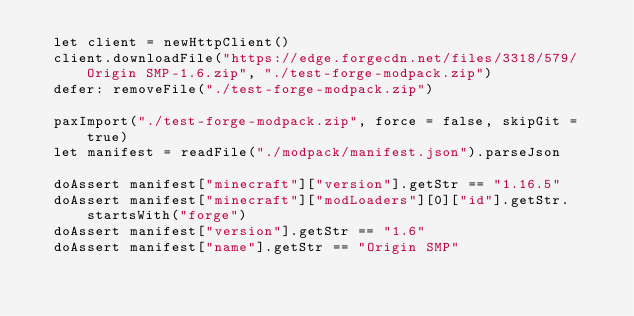Convert code to text. <code><loc_0><loc_0><loc_500><loc_500><_Nim_>  let client = newHttpClient()
  client.downloadFile("https://edge.forgecdn.net/files/3318/579/Origin SMP-1.6.zip", "./test-forge-modpack.zip")
  defer: removeFile("./test-forge-modpack.zip")

  paxImport("./test-forge-modpack.zip", force = false, skipGit = true)
  let manifest = readFile("./modpack/manifest.json").parseJson

  doAssert manifest["minecraft"]["version"].getStr == "1.16.5"
  doAssert manifest["minecraft"]["modLoaders"][0]["id"].getStr.startsWith("forge")
  doAssert manifest["version"].getStr == "1.6"
  doAssert manifest["name"].getStr == "Origin SMP"</code> 